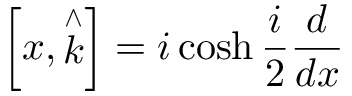<formula> <loc_0><loc_0><loc_500><loc_500>\left [ x , \stackrel { \wedge } { k } \right ] = i \cosh \frac { i } { 2 } \frac { d } { d x }</formula> 